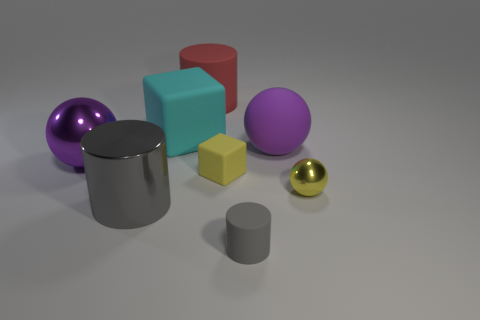Add 2 yellow objects. How many objects exist? 10 Subtract all spheres. How many objects are left? 5 Subtract all brown rubber cylinders. Subtract all big shiny objects. How many objects are left? 6 Add 2 large cyan cubes. How many large cyan cubes are left? 3 Add 5 tiny gray cubes. How many tiny gray cubes exist? 5 Subtract 0 gray cubes. How many objects are left? 8 